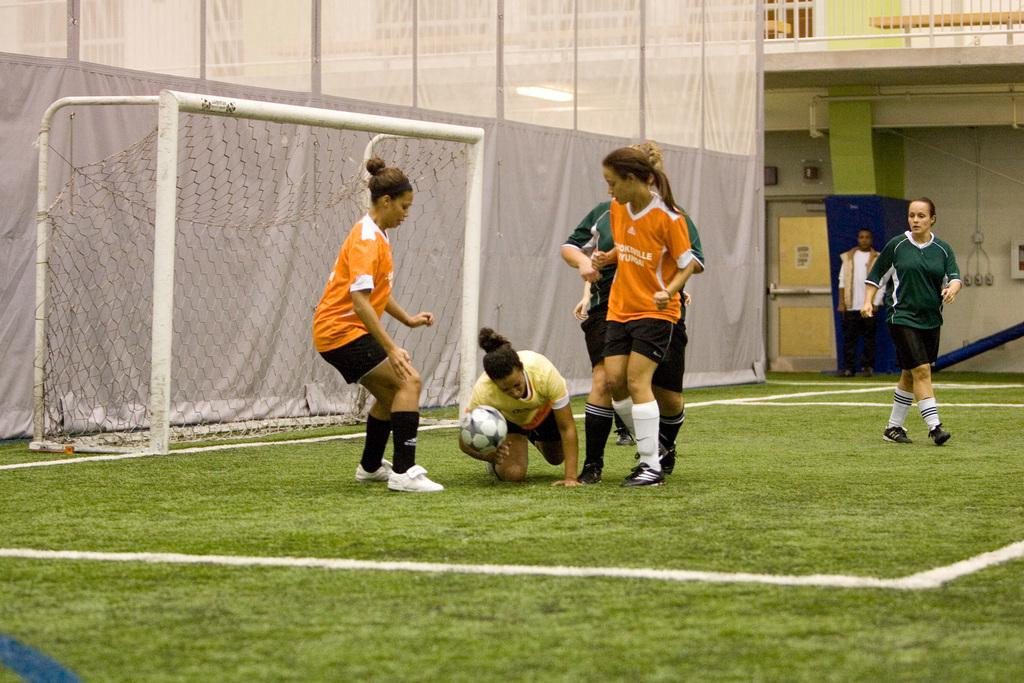What is happening in the image involving a group of people? There is a group of people in the image, and they are on the ground. What object is being held by one of the people in the image? One person is holding a ball in the image. What can be seen in the background of the image? There is a net in the background of the image. What type of picture is hanging on the wall in the image? There is no wall or picture visible in the image; it features a group of people on the ground with a ball and a net in the background. 